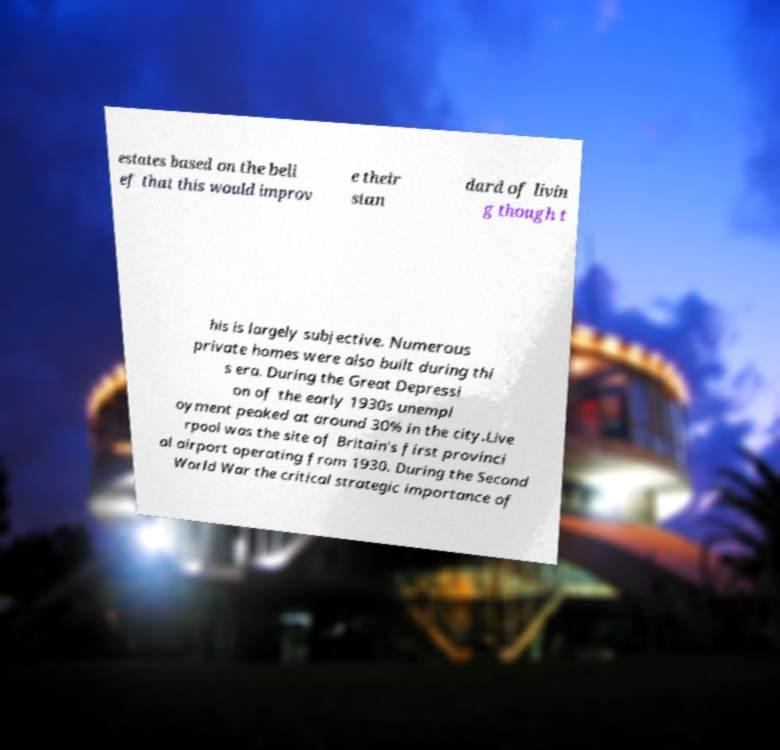Could you assist in decoding the text presented in this image and type it out clearly? estates based on the beli ef that this would improv e their stan dard of livin g though t his is largely subjective. Numerous private homes were also built during thi s era. During the Great Depressi on of the early 1930s unempl oyment peaked at around 30% in the city.Live rpool was the site of Britain's first provinci al airport operating from 1930. During the Second World War the critical strategic importance of 